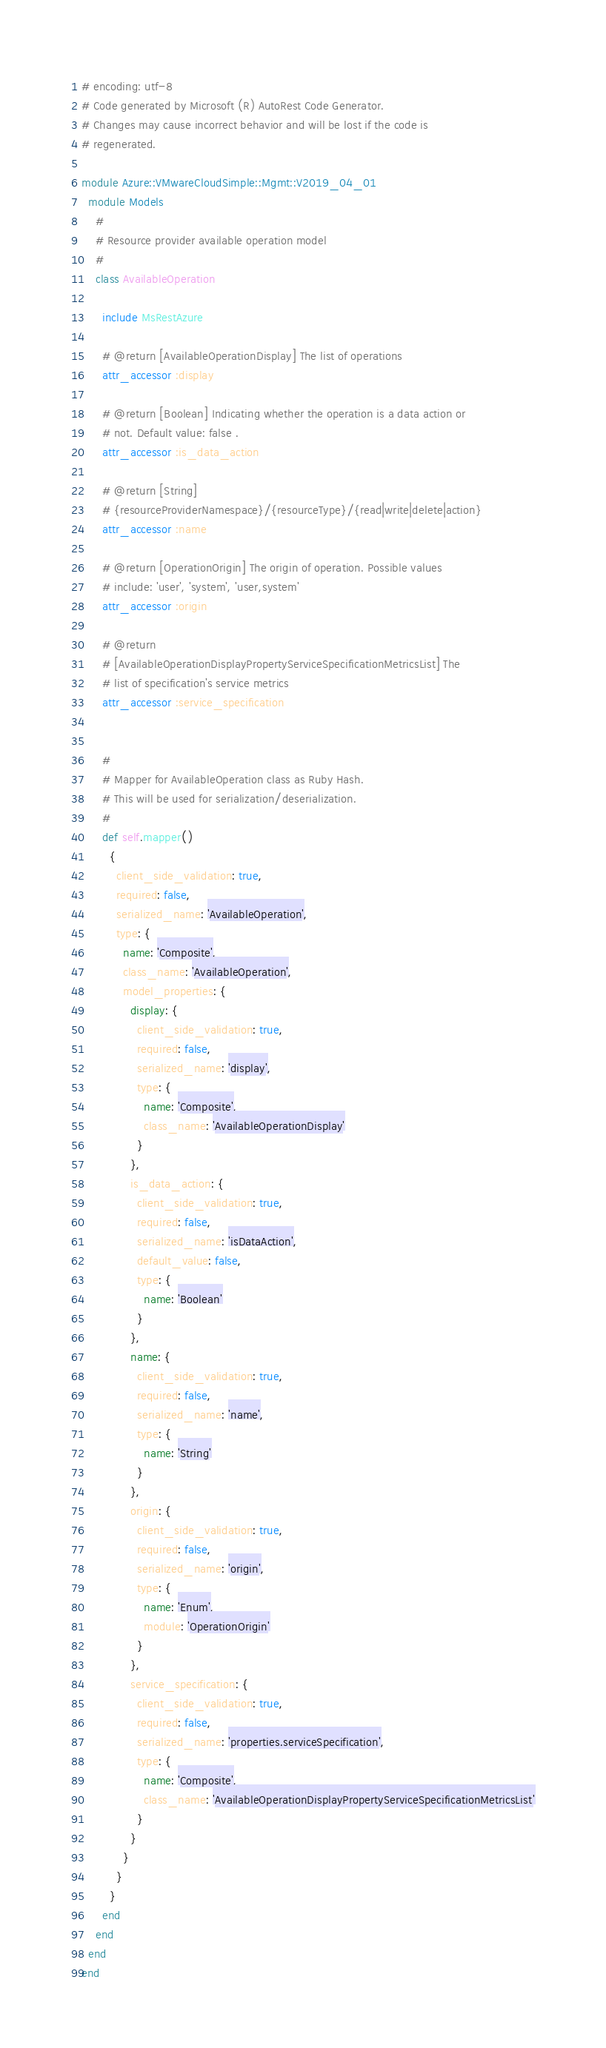<code> <loc_0><loc_0><loc_500><loc_500><_Ruby_># encoding: utf-8
# Code generated by Microsoft (R) AutoRest Code Generator.
# Changes may cause incorrect behavior and will be lost if the code is
# regenerated.

module Azure::VMwareCloudSimple::Mgmt::V2019_04_01
  module Models
    #
    # Resource provider available operation model
    #
    class AvailableOperation

      include MsRestAzure

      # @return [AvailableOperationDisplay] The list of operations
      attr_accessor :display

      # @return [Boolean] Indicating whether the operation is a data action or
      # not. Default value: false .
      attr_accessor :is_data_action

      # @return [String]
      # {resourceProviderNamespace}/{resourceType}/{read|write|delete|action}
      attr_accessor :name

      # @return [OperationOrigin] The origin of operation. Possible values
      # include: 'user', 'system', 'user,system'
      attr_accessor :origin

      # @return
      # [AvailableOperationDisplayPropertyServiceSpecificationMetricsList] The
      # list of specification's service metrics
      attr_accessor :service_specification


      #
      # Mapper for AvailableOperation class as Ruby Hash.
      # This will be used for serialization/deserialization.
      #
      def self.mapper()
        {
          client_side_validation: true,
          required: false,
          serialized_name: 'AvailableOperation',
          type: {
            name: 'Composite',
            class_name: 'AvailableOperation',
            model_properties: {
              display: {
                client_side_validation: true,
                required: false,
                serialized_name: 'display',
                type: {
                  name: 'Composite',
                  class_name: 'AvailableOperationDisplay'
                }
              },
              is_data_action: {
                client_side_validation: true,
                required: false,
                serialized_name: 'isDataAction',
                default_value: false,
                type: {
                  name: 'Boolean'
                }
              },
              name: {
                client_side_validation: true,
                required: false,
                serialized_name: 'name',
                type: {
                  name: 'String'
                }
              },
              origin: {
                client_side_validation: true,
                required: false,
                serialized_name: 'origin',
                type: {
                  name: 'Enum',
                  module: 'OperationOrigin'
                }
              },
              service_specification: {
                client_side_validation: true,
                required: false,
                serialized_name: 'properties.serviceSpecification',
                type: {
                  name: 'Composite',
                  class_name: 'AvailableOperationDisplayPropertyServiceSpecificationMetricsList'
                }
              }
            }
          }
        }
      end
    end
  end
end
</code> 